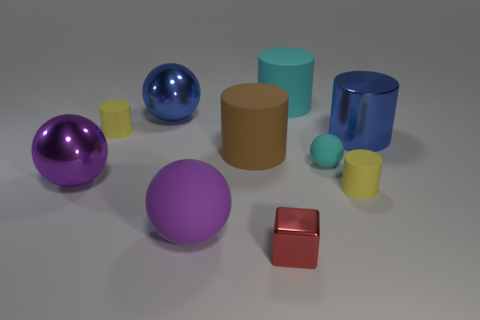How many purple balls must be subtracted to get 1 purple balls? 1 Subtract 0 red spheres. How many objects are left? 10 Subtract all cubes. How many objects are left? 9 Subtract 4 cylinders. How many cylinders are left? 1 Subtract all brown spheres. Subtract all brown cylinders. How many spheres are left? 4 Subtract all yellow cylinders. How many cyan blocks are left? 0 Subtract all blue metallic spheres. Subtract all rubber objects. How many objects are left? 3 Add 7 yellow matte cylinders. How many yellow matte cylinders are left? 9 Add 6 brown cylinders. How many brown cylinders exist? 7 Subtract all blue spheres. How many spheres are left? 3 